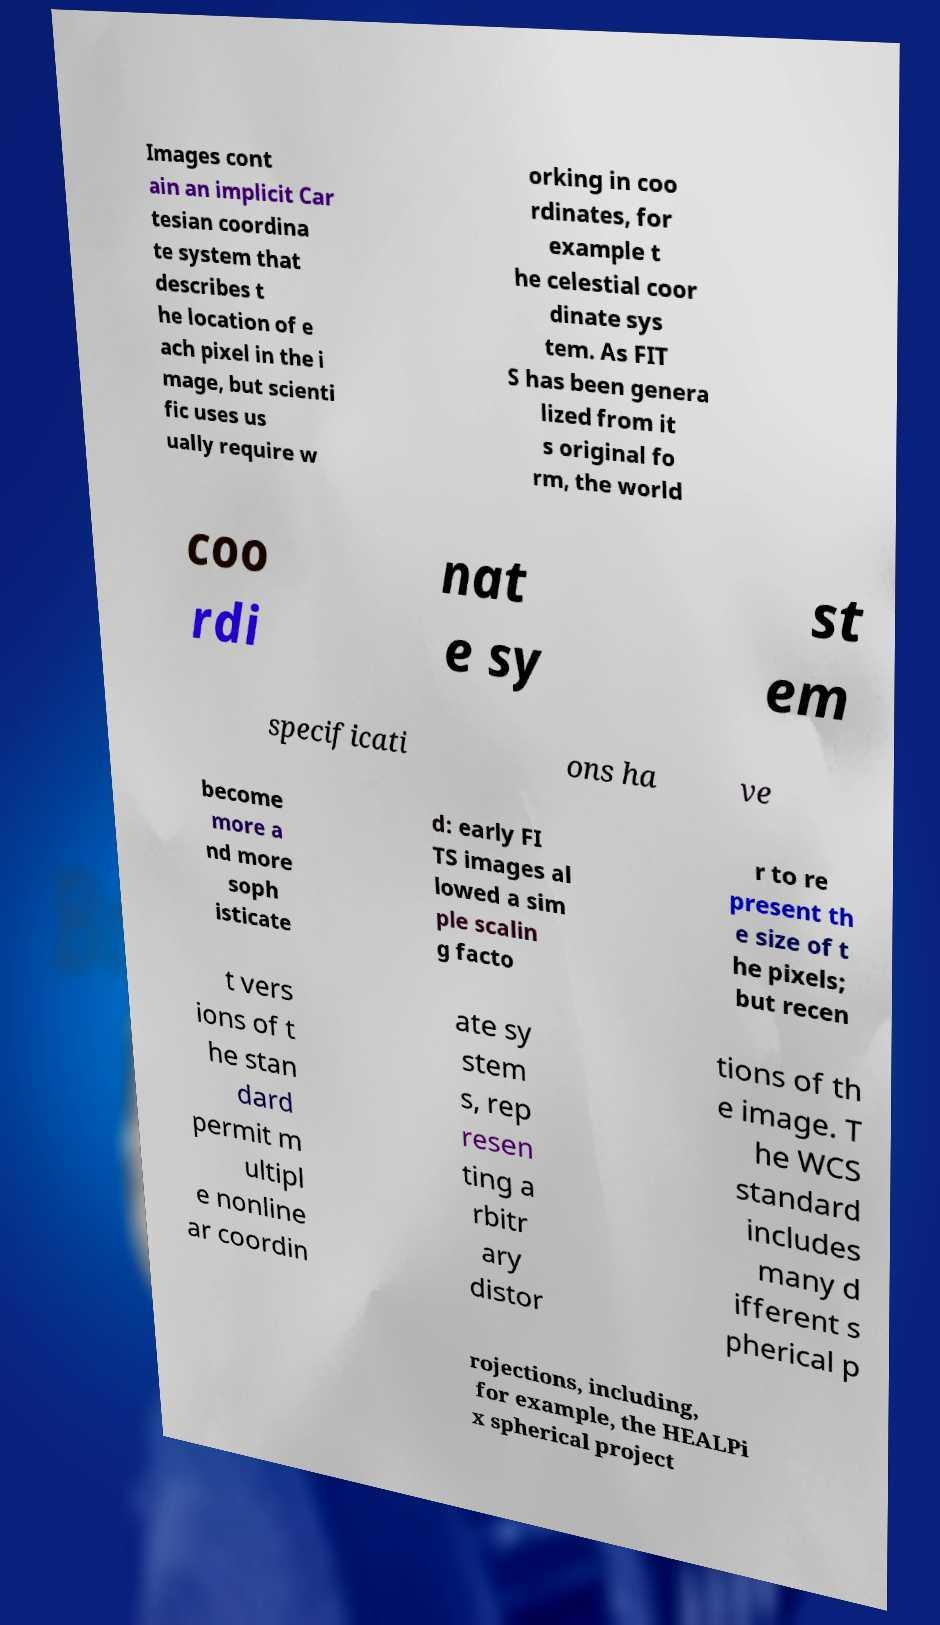There's text embedded in this image that I need extracted. Can you transcribe it verbatim? Images cont ain an implicit Car tesian coordina te system that describes t he location of e ach pixel in the i mage, but scienti fic uses us ually require w orking in coo rdinates, for example t he celestial coor dinate sys tem. As FIT S has been genera lized from it s original fo rm, the world coo rdi nat e sy st em specificati ons ha ve become more a nd more soph isticate d: early FI TS images al lowed a sim ple scalin g facto r to re present th e size of t he pixels; but recen t vers ions of t he stan dard permit m ultipl e nonline ar coordin ate sy stem s, rep resen ting a rbitr ary distor tions of th e image. T he WCS standard includes many d ifferent s pherical p rojections, including, for example, the HEALPi x spherical project 